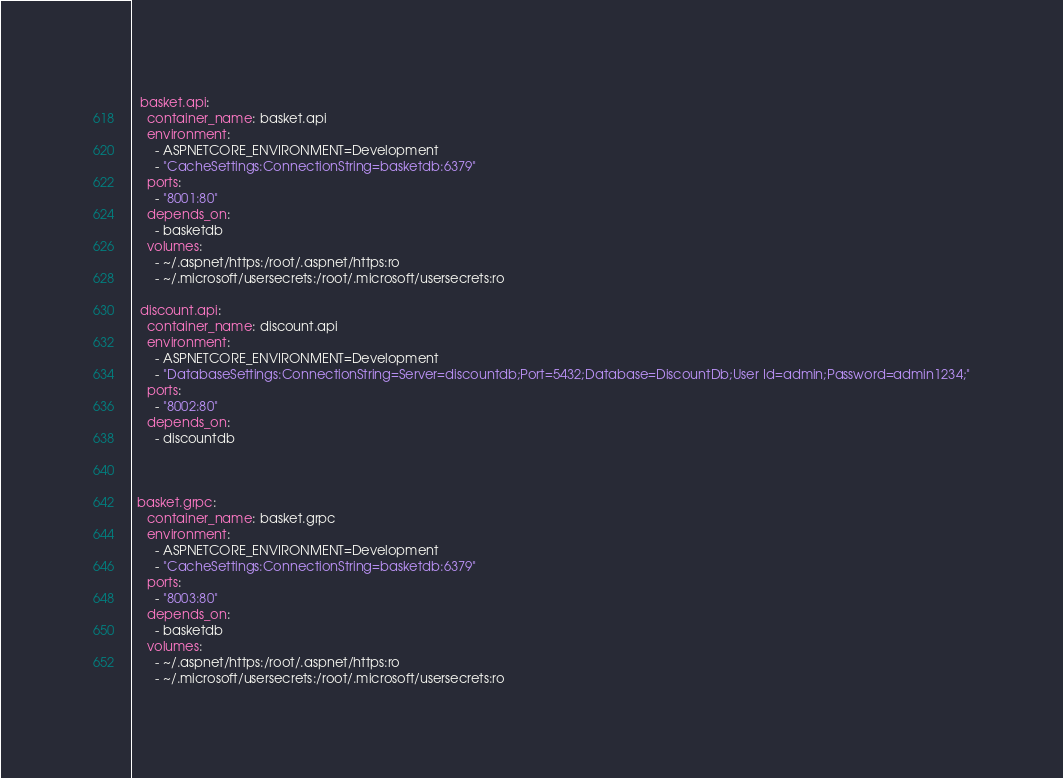Convert code to text. <code><loc_0><loc_0><loc_500><loc_500><_YAML_>

  basket.api:
    container_name: basket.api
    environment:
      - ASPNETCORE_ENVIRONMENT=Development
      - "CacheSettings:ConnectionString=basketdb:6379"
    ports:
      - "8001:80"
    depends_on:
      - basketdb
    volumes:
      - ~/.aspnet/https:/root/.aspnet/https:ro
      - ~/.microsoft/usersecrets:/root/.microsoft/usersecrets:ro

  discount.api:
    container_name: discount.api
    environment:
      - ASPNETCORE_ENVIRONMENT=Development
      - "DatabaseSettings:ConnectionString=Server=discountdb;Port=5432;Database=DiscountDb;User Id=admin;Password=admin1234;"
    ports:
      - "8002:80"
    depends_on:
      - discountdb

    
  
 basket.grpc:
    container_name: basket.grpc
    environment:
      - ASPNETCORE_ENVIRONMENT=Development
      - "CacheSettings:ConnectionString=basketdb:6379"
    ports:
      - "8003:80"
    depends_on:
      - basketdb
    volumes:
      - ~/.aspnet/https:/root/.aspnet/https:ro
      - ~/.microsoft/usersecrets:/root/.microsoft/usersecrets:ro

</code> 